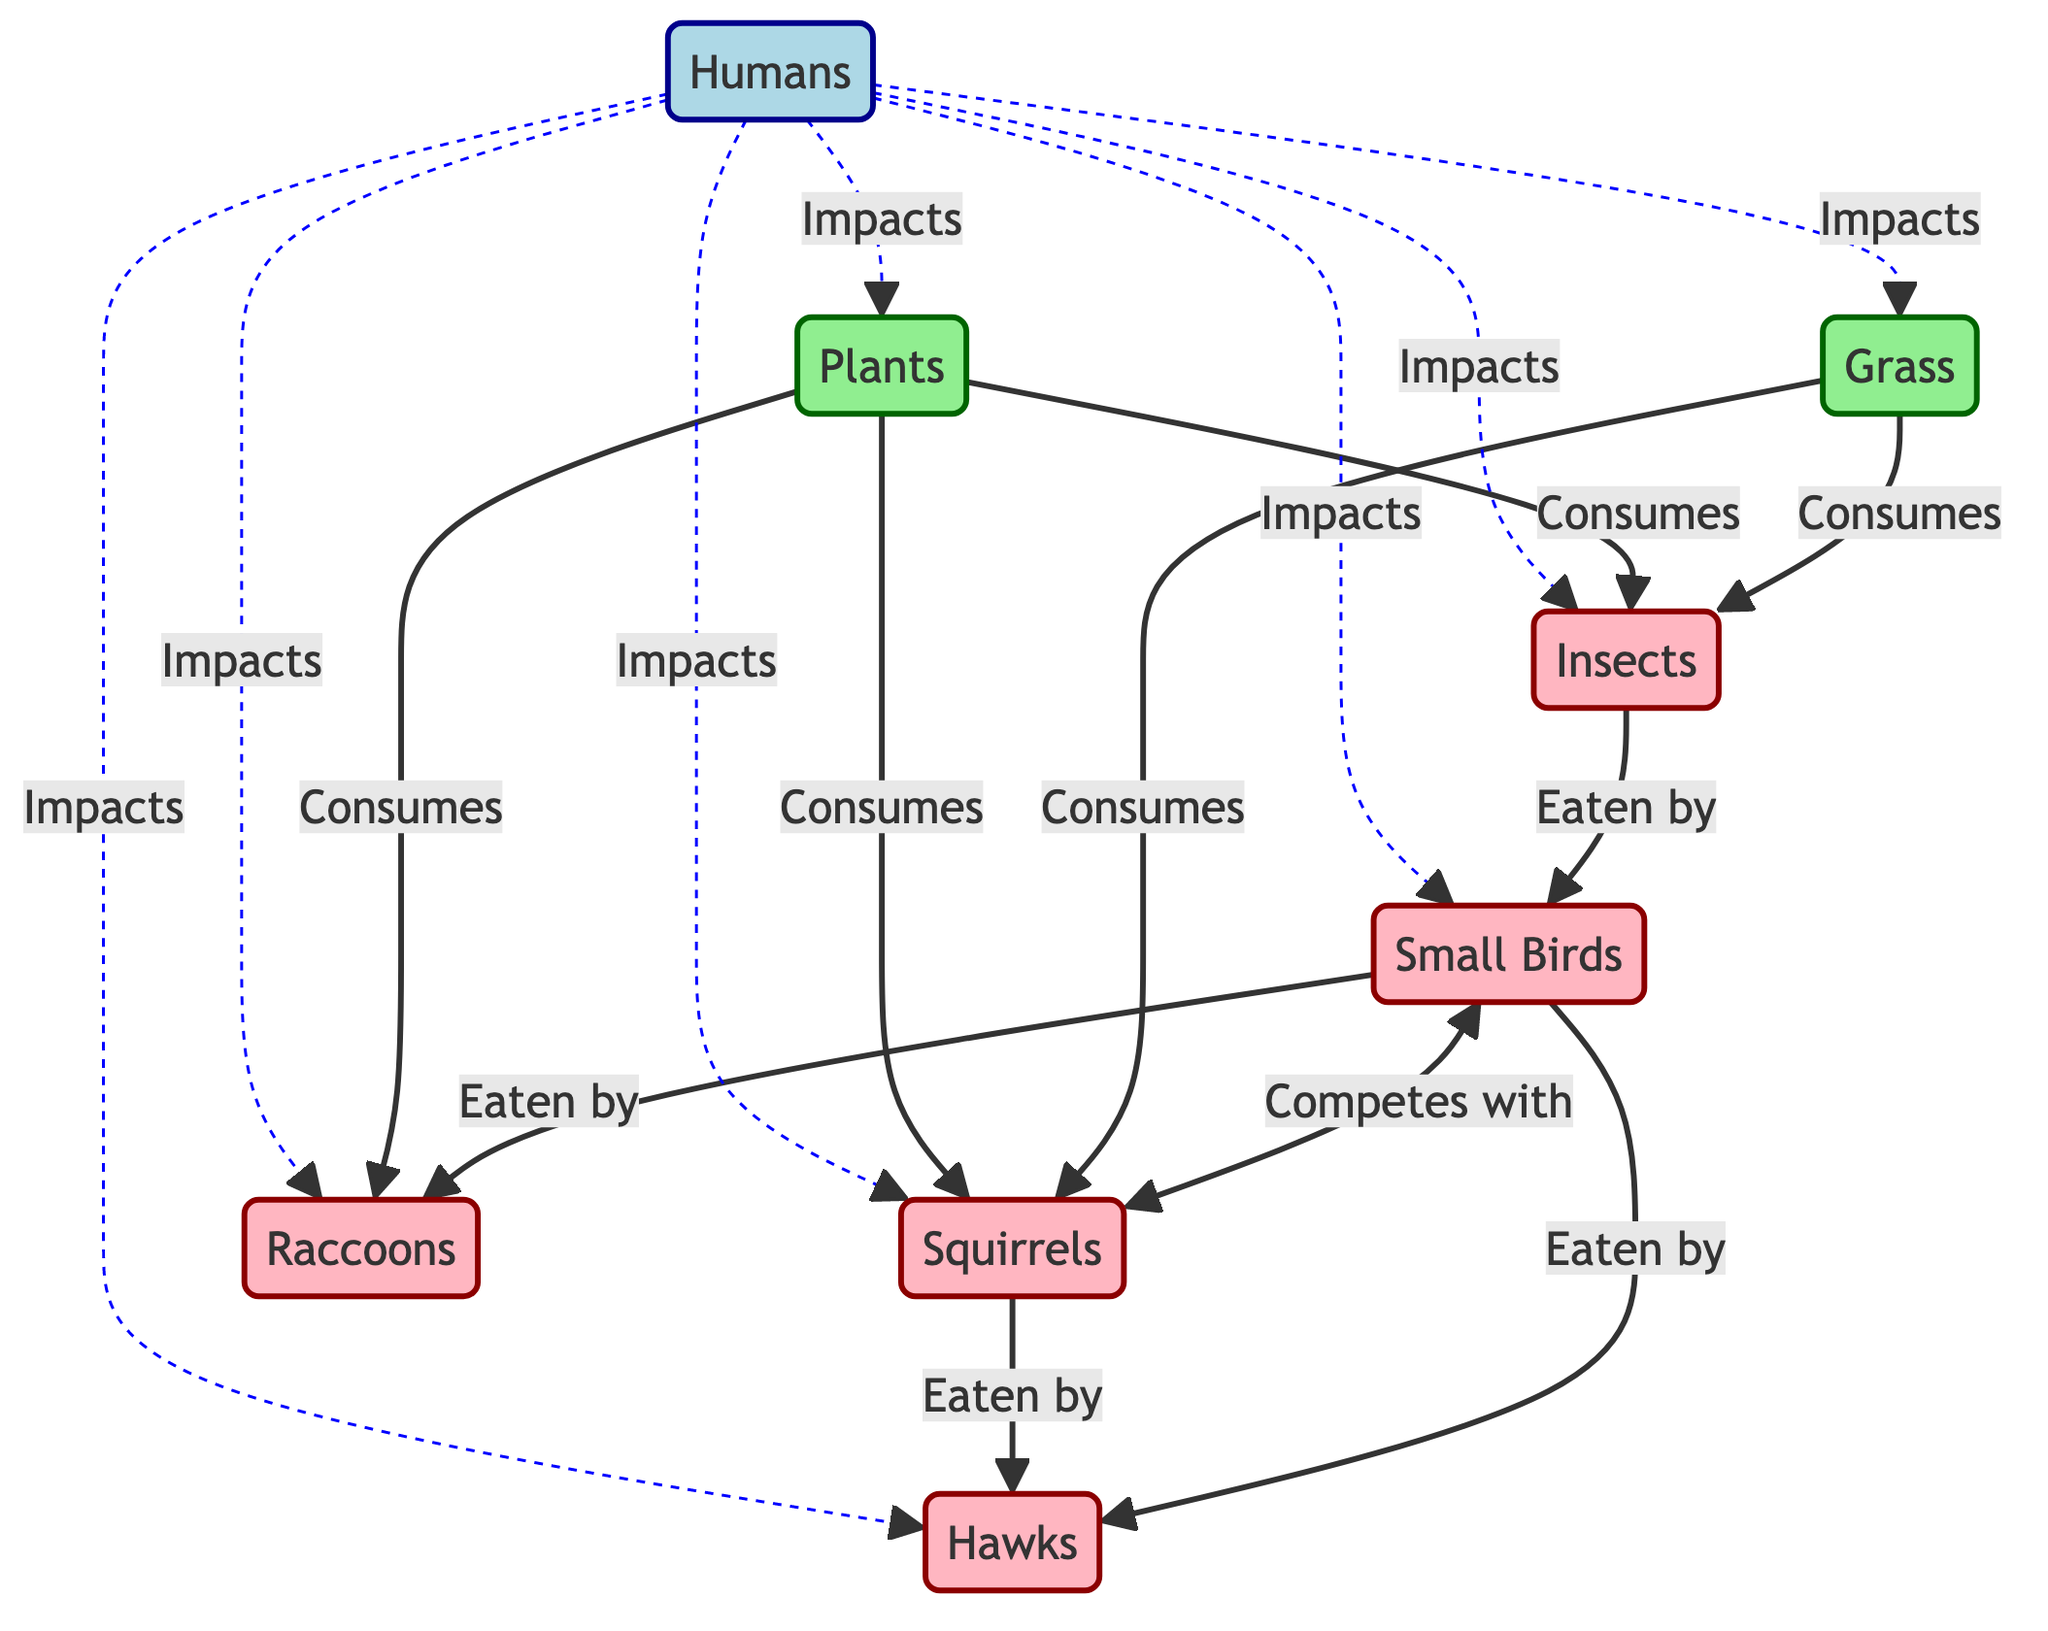What are the producers in this food chain? The producers in the food chain are the organisms that create energy for the ecosystem. In the diagram, these are indicated by the "producer" class, which includes grass and plants.
Answer: grass, plants How many consumer nodes are present in the diagram? To find the number of consumer nodes, we count each node classified as "consumer." The consumers listed are insects, small birds, hawks, squirrels, and raccoons, totaling five consumer nodes.
Answer: 5 What competes with small birds? The diagram indicates that squirrels compete with small birds, as shown by the bidirectional arrow labeled "Competes with" between the two nodes.
Answer: squirrels Which consumer is at the top of the food chain? The top consumer, or apex predator, is represented by "hawks" in the diagram, as they eat small birds and squirrels and have no predators shown above them.
Answer: hawks How do humans impact insects? The diagram shows a dashed line from "humans" to "insects," indicating an impact relationship. This means humans affect insects in the urban food chain, likely through actions such as pollution or habitat alteration.
Answer: Impacts Which organisms are eaten by hawks? According to the diagram, hawks eat small birds and squirrels. This is shown clearly with arrows directed from both of these consumer nodes to the hawk node.
Answer: small birds, squirrels What do plants consume according to the diagram? The diagram shows arrows from "plants" to three consumer nodes: insects, squirrels, and raccoons, indicating that plants provide energy or nutrients to these organisms.
Answer: insects, squirrels, raccoons Count the total number of interactions shown in the diagram. By counting all the arrows that represent interactions between the nodes, including consumption and competition, we find a total of eight distinct interactions present in the flowchart.
Answer: 8 How are humans involved in this food chain? The diagram indicates humans have an impact on all the other elements—grass, plants, insects, small birds, hawks, squirrels, and raccoons—demonstrated by dashed lines connecting them all back to the human node.
Answer: Impacts 